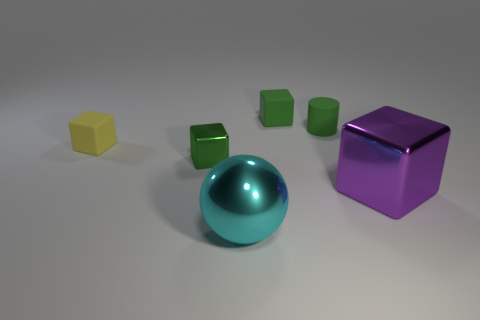Add 4 tiny yellow matte blocks. How many objects exist? 10 Subtract all small cubes. How many cubes are left? 1 Subtract all purple cubes. How many cubes are left? 3 Subtract all cylinders. How many objects are left? 5 Subtract 3 blocks. How many blocks are left? 1 Subtract all purple cubes. Subtract all blue cylinders. How many cubes are left? 3 Subtract all green cylinders. How many purple balls are left? 0 Subtract all large brown things. Subtract all shiny balls. How many objects are left? 5 Add 5 small green shiny cubes. How many small green shiny cubes are left? 6 Add 2 tiny blue balls. How many tiny blue balls exist? 2 